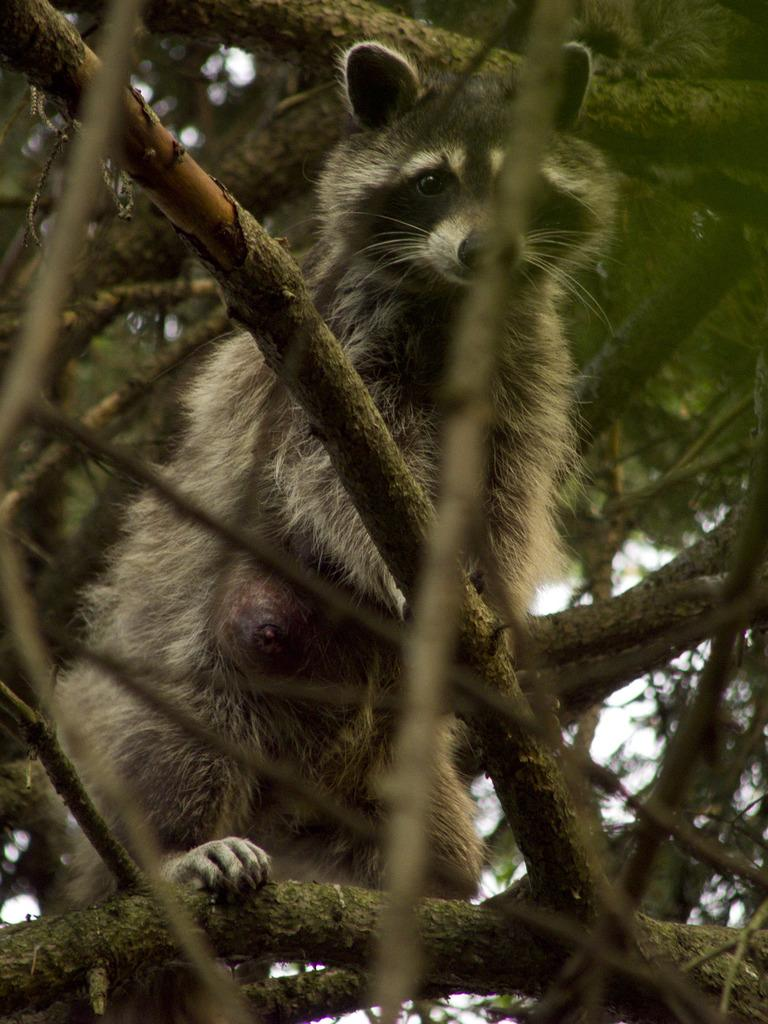What animals are present in the image? There are raccoons in the image. What color are the raccoons? The raccoons are brown in color. Where are the raccoons located in the image? The raccoons are sitting on a tree branch. What type of vegetation can be seen in the image? There are green leaves visible in the image. How many times do the raccoons sneeze in the image? There is no indication in the image that the raccoons are sneezing, so it cannot be determined from the picture. 